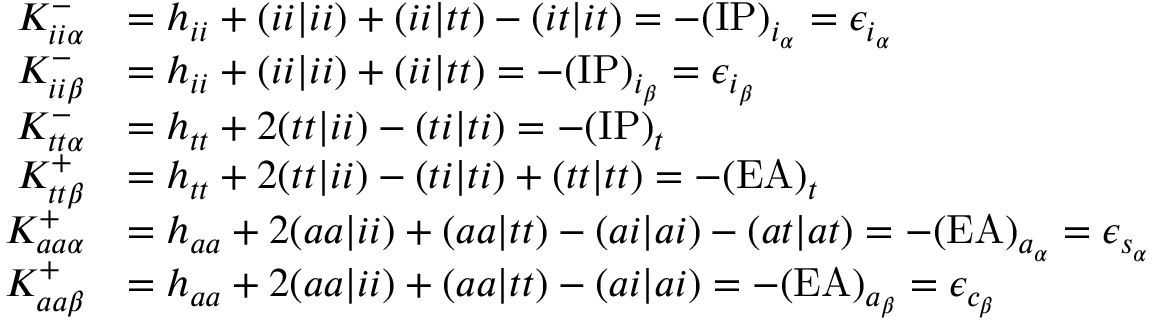<formula> <loc_0><loc_0><loc_500><loc_500>\begin{array} { r l } { K _ { i i \alpha } ^ { - } } & { = h _ { i i } + ( i i | i i ) + ( i i | t t ) - ( i t | i t ) = - ( I P ) _ { i _ { \alpha } } = \epsilon _ { i _ { \alpha } } } \\ { K _ { i i \beta } ^ { - } } & { = h _ { i i } + ( i i | i i ) + ( i i | t t ) = - ( I P ) _ { i _ { \beta } } = \epsilon _ { i _ { \beta } } } \\ { K _ { t t \alpha } ^ { - } } & { = h _ { t t } + 2 ( t t | i i ) - ( t i | t i ) = - ( I P ) _ { t } } \\ { K _ { t t \beta } ^ { + } } & { = h _ { t t } + 2 ( t t | i i ) - ( t i | t i ) + ( t t | t t ) = - ( E A ) _ { t } } \\ { K _ { a a \alpha } ^ { + } } & { = h _ { a a } + 2 ( a a | i i ) + ( a a | t t ) - ( a i | a i ) - ( a t | a t ) = - ( E A ) _ { a _ { \alpha } } = \epsilon _ { s _ { \alpha } } } \\ { K _ { a a \beta } ^ { + } } & { = h _ { a a } + 2 ( a a | i i ) + ( a a | t t ) - ( a i | a i ) = - ( E A ) _ { a _ { \beta } } = \epsilon _ { c _ { \beta } } } \end{array}</formula> 